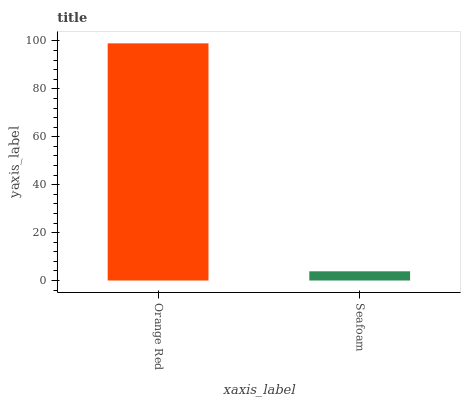Is Seafoam the minimum?
Answer yes or no. Yes. Is Orange Red the maximum?
Answer yes or no. Yes. Is Seafoam the maximum?
Answer yes or no. No. Is Orange Red greater than Seafoam?
Answer yes or no. Yes. Is Seafoam less than Orange Red?
Answer yes or no. Yes. Is Seafoam greater than Orange Red?
Answer yes or no. No. Is Orange Red less than Seafoam?
Answer yes or no. No. Is Orange Red the high median?
Answer yes or no. Yes. Is Seafoam the low median?
Answer yes or no. Yes. Is Seafoam the high median?
Answer yes or no. No. Is Orange Red the low median?
Answer yes or no. No. 